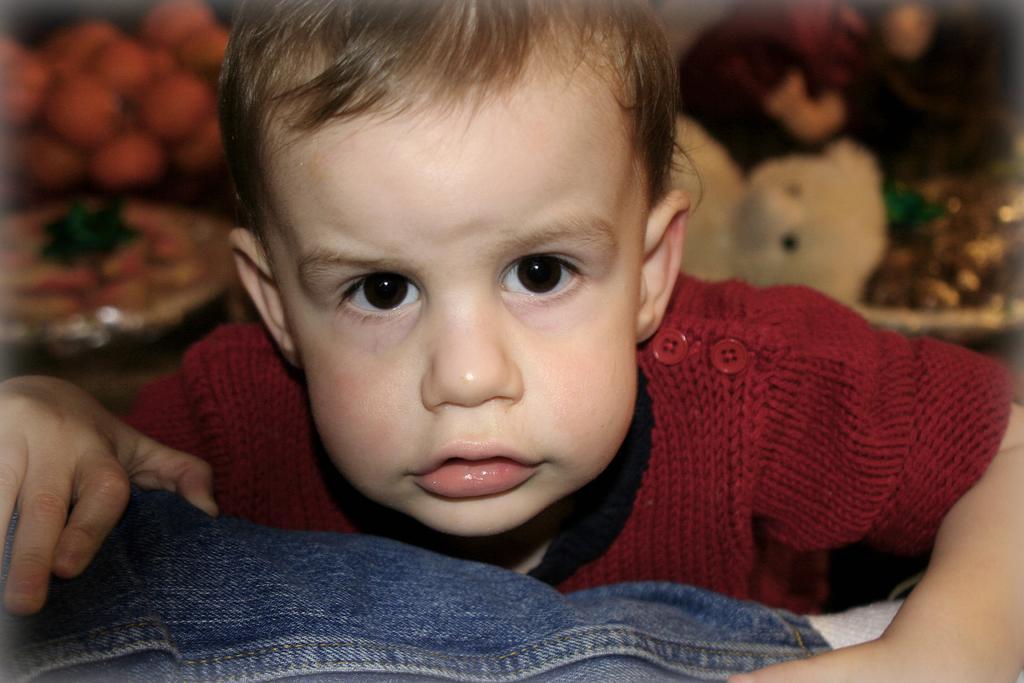Describe this image in one or two sentences. In this image there is a person wearing red shirt in the foreground. There are toys, fruits and other objects in the background. 